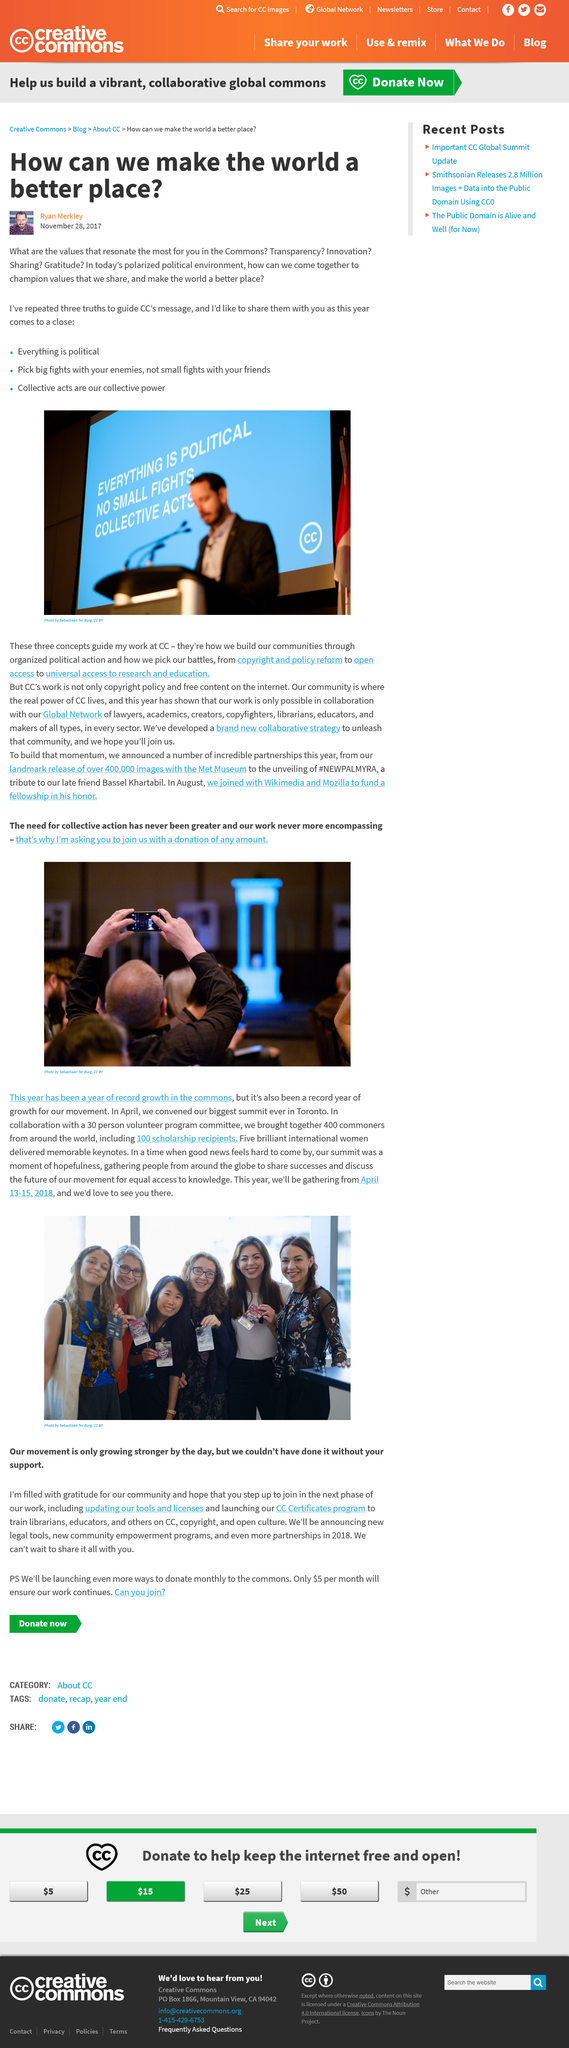Indicate a few pertinent items in this graphic. CC's message contains three truths. The man in the photo taken by Sebastiaan Ter Burg is holding a camera in his hands. The April summit was held in Toronto, the city where it took place. The political environment is not united as many people believe, but rather polarized according to the respondents' opinions. Five international women delivered keynotes at the summit. 